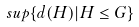<formula> <loc_0><loc_0><loc_500><loc_500>s u p \{ d ( H ) | H \leq G \}</formula> 